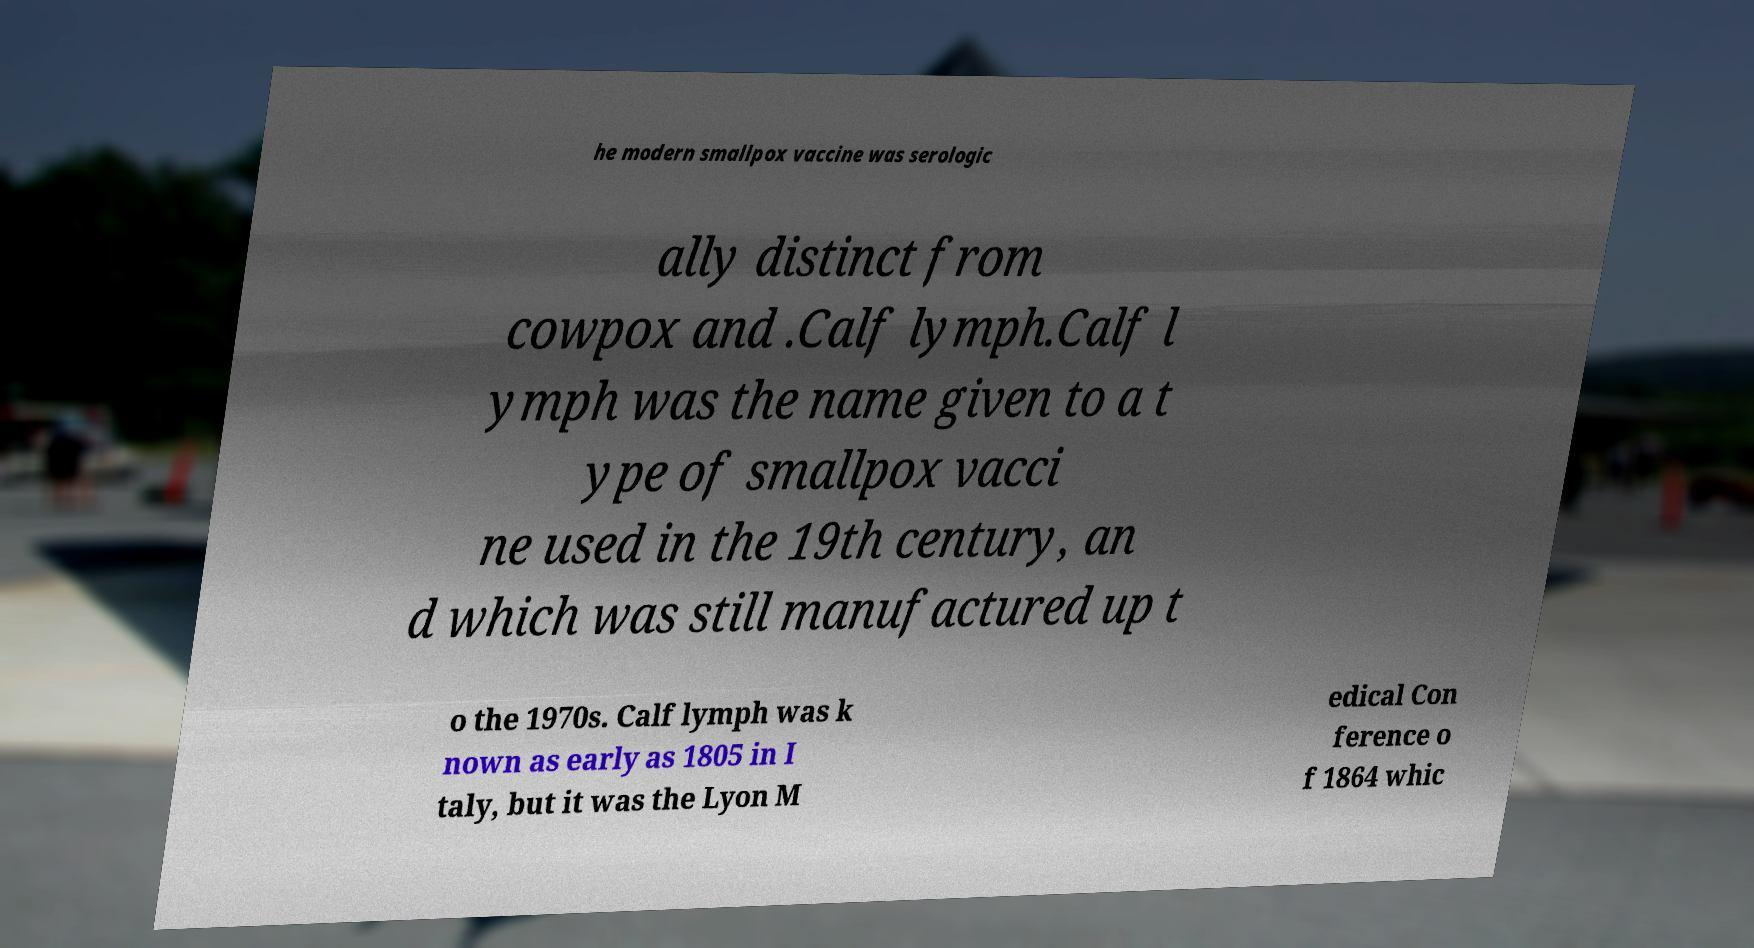Could you extract and type out the text from this image? he modern smallpox vaccine was serologic ally distinct from cowpox and .Calf lymph.Calf l ymph was the name given to a t ype of smallpox vacci ne used in the 19th century, an d which was still manufactured up t o the 1970s. Calf lymph was k nown as early as 1805 in I taly, but it was the Lyon M edical Con ference o f 1864 whic 